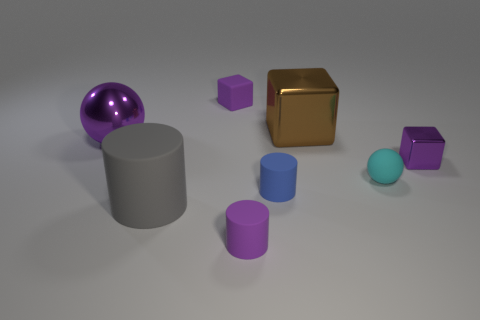Add 2 yellow metallic cylinders. How many objects exist? 10 Subtract all balls. How many objects are left? 6 Subtract 1 cyan balls. How many objects are left? 7 Subtract all small gray shiny spheres. Subtract all large purple metallic objects. How many objects are left? 7 Add 7 cyan balls. How many cyan balls are left? 8 Add 1 big cyan rubber blocks. How many big cyan rubber blocks exist? 1 